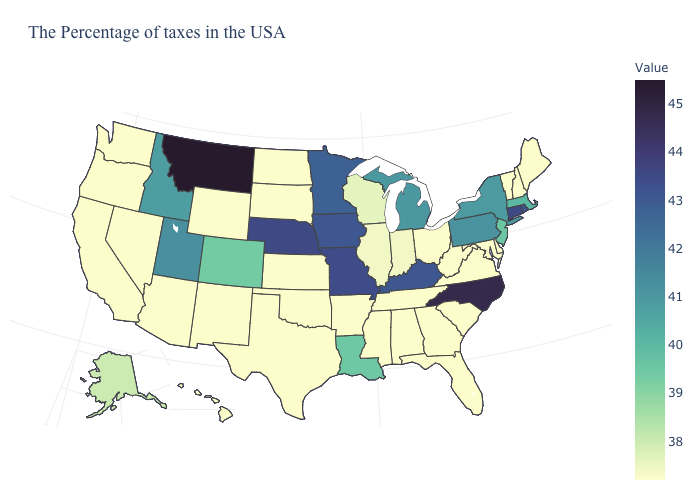Among the states that border Alabama , which have the highest value?
Concise answer only. Florida, Georgia, Tennessee, Mississippi. Which states have the lowest value in the USA?
Answer briefly. Maine, New Hampshire, Vermont, Delaware, Maryland, Virginia, South Carolina, West Virginia, Ohio, Florida, Georgia, Alabama, Tennessee, Mississippi, Arkansas, Kansas, Oklahoma, Texas, South Dakota, North Dakota, Wyoming, New Mexico, Arizona, Nevada, California, Washington, Oregon, Hawaii. Among the states that border Utah , which have the highest value?
Give a very brief answer. Idaho. Does Connecticut have the highest value in the Northeast?
Write a very short answer. Yes. 